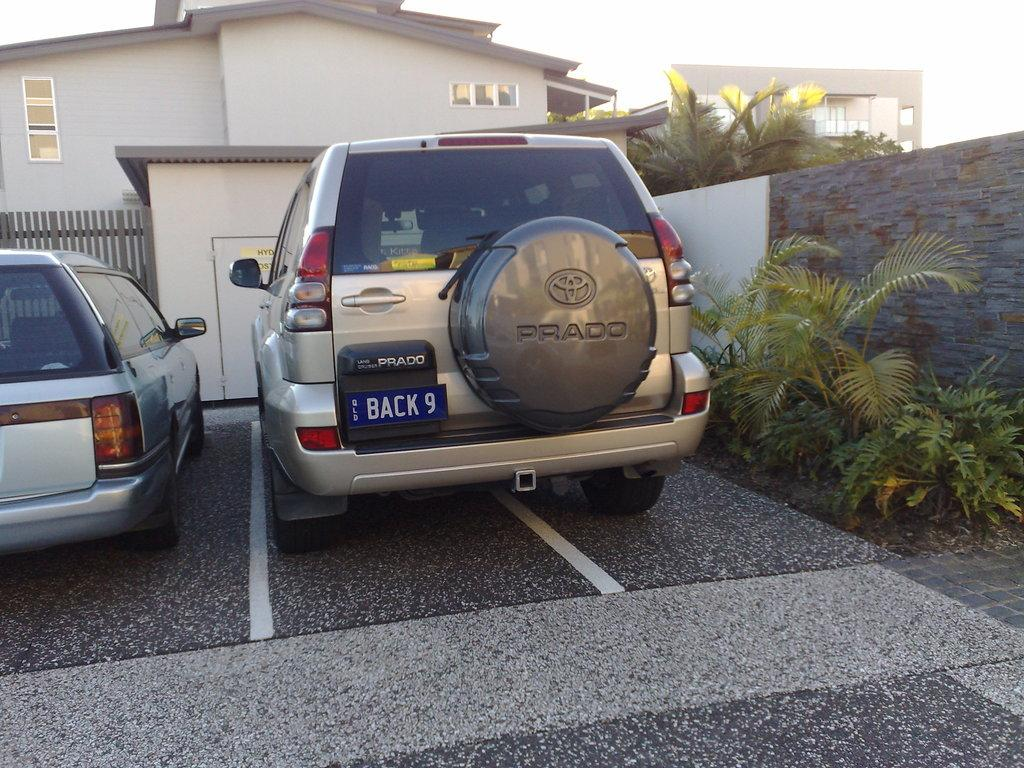How many cars are parked in the image? There are two cars parked in the image. Where are the cars located? The cars are in a parking lot. What can be seen in the background of the image? There are buildings, trees, plants, and the sky visible in the background of the image. What is the interest rate on the car loans in the image? There is no information about car loans or interest rates in the image. 